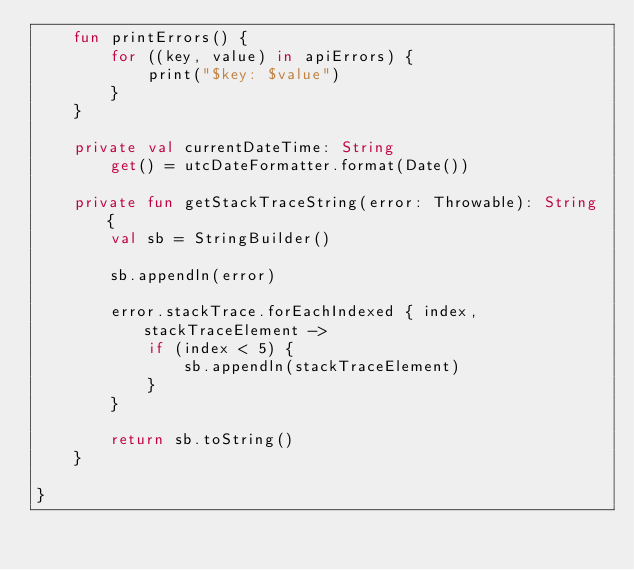<code> <loc_0><loc_0><loc_500><loc_500><_Kotlin_>    fun printErrors() {
        for ((key, value) in apiErrors) {
            print("$key: $value")
        }
    }

    private val currentDateTime: String
        get() = utcDateFormatter.format(Date())

    private fun getStackTraceString(error: Throwable): String {
        val sb = StringBuilder()

        sb.appendln(error)

        error.stackTrace.forEachIndexed { index, stackTraceElement ->
            if (index < 5) {
                sb.appendln(stackTraceElement)
            }
        }

        return sb.toString()
    }

}
</code> 